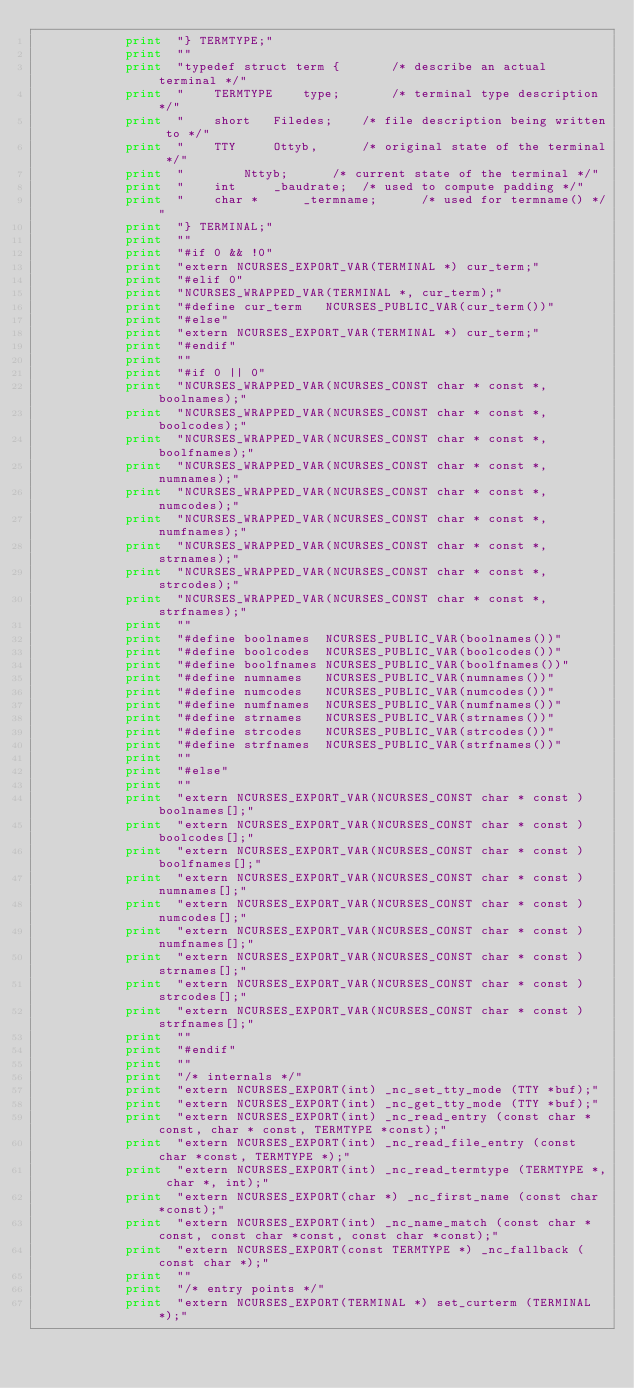<code> <loc_0><loc_0><loc_500><loc_500><_Awk_>			print  "} TERMTYPE;"
			print  ""
			print  "typedef struct term {		/* describe an actual terminal */"
			print  "    TERMTYPE	type;		/* terminal type description */"
			print  "    short	Filedes;	/* file description being written to */"
			print  "    TTY		Ottyb,		/* original state of the terminal */"
			print  "		Nttyb;		/* current state of the terminal */"
			print  "    int		_baudrate;	/* used to compute padding */"
			print  "    char *      _termname;      /* used for termname() */"
			print  "} TERMINAL;"
			print  ""
			print  "#if 0 && !0"
			print  "extern NCURSES_EXPORT_VAR(TERMINAL *) cur_term;"
			print  "#elif 0"
			print  "NCURSES_WRAPPED_VAR(TERMINAL *, cur_term);"
			print  "#define cur_term   NCURSES_PUBLIC_VAR(cur_term())"
			print  "#else"
			print  "extern NCURSES_EXPORT_VAR(TERMINAL *) cur_term;"
			print  "#endif"
			print  ""
			print  "#if 0 || 0"
			print  "NCURSES_WRAPPED_VAR(NCURSES_CONST char * const *, boolnames);"
			print  "NCURSES_WRAPPED_VAR(NCURSES_CONST char * const *, boolcodes);"
			print  "NCURSES_WRAPPED_VAR(NCURSES_CONST char * const *, boolfnames);"
			print  "NCURSES_WRAPPED_VAR(NCURSES_CONST char * const *, numnames);"
			print  "NCURSES_WRAPPED_VAR(NCURSES_CONST char * const *, numcodes);"
			print  "NCURSES_WRAPPED_VAR(NCURSES_CONST char * const *, numfnames);"
			print  "NCURSES_WRAPPED_VAR(NCURSES_CONST char * const *, strnames);"
			print  "NCURSES_WRAPPED_VAR(NCURSES_CONST char * const *, strcodes);"
			print  "NCURSES_WRAPPED_VAR(NCURSES_CONST char * const *, strfnames);"
			print  ""
			print  "#define boolnames  NCURSES_PUBLIC_VAR(boolnames())"
			print  "#define boolcodes  NCURSES_PUBLIC_VAR(boolcodes())"
			print  "#define boolfnames NCURSES_PUBLIC_VAR(boolfnames())"
			print  "#define numnames   NCURSES_PUBLIC_VAR(numnames())"
			print  "#define numcodes   NCURSES_PUBLIC_VAR(numcodes())"
			print  "#define numfnames  NCURSES_PUBLIC_VAR(numfnames())"
			print  "#define strnames   NCURSES_PUBLIC_VAR(strnames())"
			print  "#define strcodes   NCURSES_PUBLIC_VAR(strcodes())"
			print  "#define strfnames  NCURSES_PUBLIC_VAR(strfnames())"
			print  ""
			print  "#else"
			print  ""
			print  "extern NCURSES_EXPORT_VAR(NCURSES_CONST char * const ) boolnames[];"
			print  "extern NCURSES_EXPORT_VAR(NCURSES_CONST char * const ) boolcodes[];"
			print  "extern NCURSES_EXPORT_VAR(NCURSES_CONST char * const ) boolfnames[];"
			print  "extern NCURSES_EXPORT_VAR(NCURSES_CONST char * const ) numnames[];"
			print  "extern NCURSES_EXPORT_VAR(NCURSES_CONST char * const ) numcodes[];"
			print  "extern NCURSES_EXPORT_VAR(NCURSES_CONST char * const ) numfnames[];"
			print  "extern NCURSES_EXPORT_VAR(NCURSES_CONST char * const ) strnames[];"
			print  "extern NCURSES_EXPORT_VAR(NCURSES_CONST char * const ) strcodes[];"
			print  "extern NCURSES_EXPORT_VAR(NCURSES_CONST char * const ) strfnames[];"
			print  ""
			print  "#endif"
			print  ""
			print  "/* internals */"
			print  "extern NCURSES_EXPORT(int) _nc_set_tty_mode (TTY *buf);"
			print  "extern NCURSES_EXPORT(int) _nc_get_tty_mode (TTY *buf);"
			print  "extern NCURSES_EXPORT(int) _nc_read_entry (const char * const, char * const, TERMTYPE *const);"
			print  "extern NCURSES_EXPORT(int) _nc_read_file_entry (const char *const, TERMTYPE *);"
			print  "extern NCURSES_EXPORT(int) _nc_read_termtype (TERMTYPE *, char *, int);"
			print  "extern NCURSES_EXPORT(char *) _nc_first_name (const char *const);"
			print  "extern NCURSES_EXPORT(int) _nc_name_match (const char *const, const char *const, const char *const);"
			print  "extern NCURSES_EXPORT(const TERMTYPE *) _nc_fallback (const char *);"
			print  ""
			print  "/* entry points */"
			print  "extern NCURSES_EXPORT(TERMINAL *) set_curterm (TERMINAL *);"</code> 